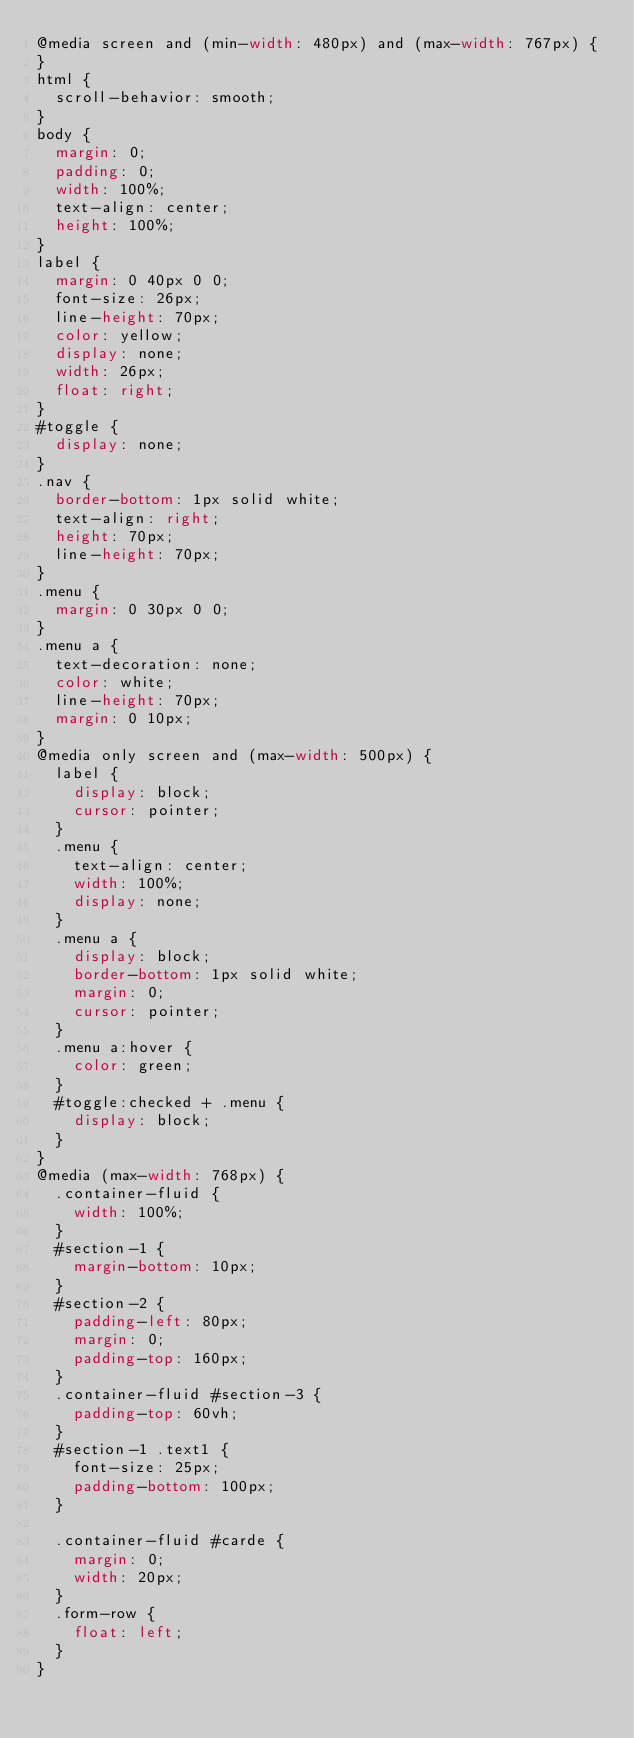<code> <loc_0><loc_0><loc_500><loc_500><_CSS_>@media screen and (min-width: 480px) and (max-width: 767px) {
}
html {
  scroll-behavior: smooth;
}
body {
  margin: 0;
  padding: 0;
  width: 100%;
  text-align: center;
  height: 100%;
}
label {
  margin: 0 40px 0 0;
  font-size: 26px;
  line-height: 70px;
  color: yellow;
  display: none;
  width: 26px;
  float: right;
}
#toggle {
  display: none;
}
.nav {
  border-bottom: 1px solid white;
  text-align: right;
  height: 70px;
  line-height: 70px;
}
.menu {
  margin: 0 30px 0 0;
}
.menu a {
  text-decoration: none;
  color: white;
  line-height: 70px;
  margin: 0 10px;
}
@media only screen and (max-width: 500px) {
  label {
    display: block;
    cursor: pointer;
  }
  .menu {
    text-align: center;
    width: 100%;
    display: none;
  }
  .menu a {
    display: block;
    border-bottom: 1px solid white;
    margin: 0;
    cursor: pointer;
  }
  .menu a:hover {
    color: green;
  }
  #toggle:checked + .menu {
    display: block;
  }
}
@media (max-width: 768px) {
  .container-fluid {
    width: 100%;
  }
  #section-1 {
    margin-bottom: 10px;
  }
  #section-2 {
    padding-left: 80px;
    margin: 0;
    padding-top: 160px;
  }
  .container-fluid #section-3 {
    padding-top: 60vh;
  }
  #section-1 .text1 {
    font-size: 25px;
    padding-bottom: 100px;
  }

  .container-fluid #carde {
    margin: 0;
    width: 20px;
  }
  .form-row {
    float: left;
  }
}</code> 